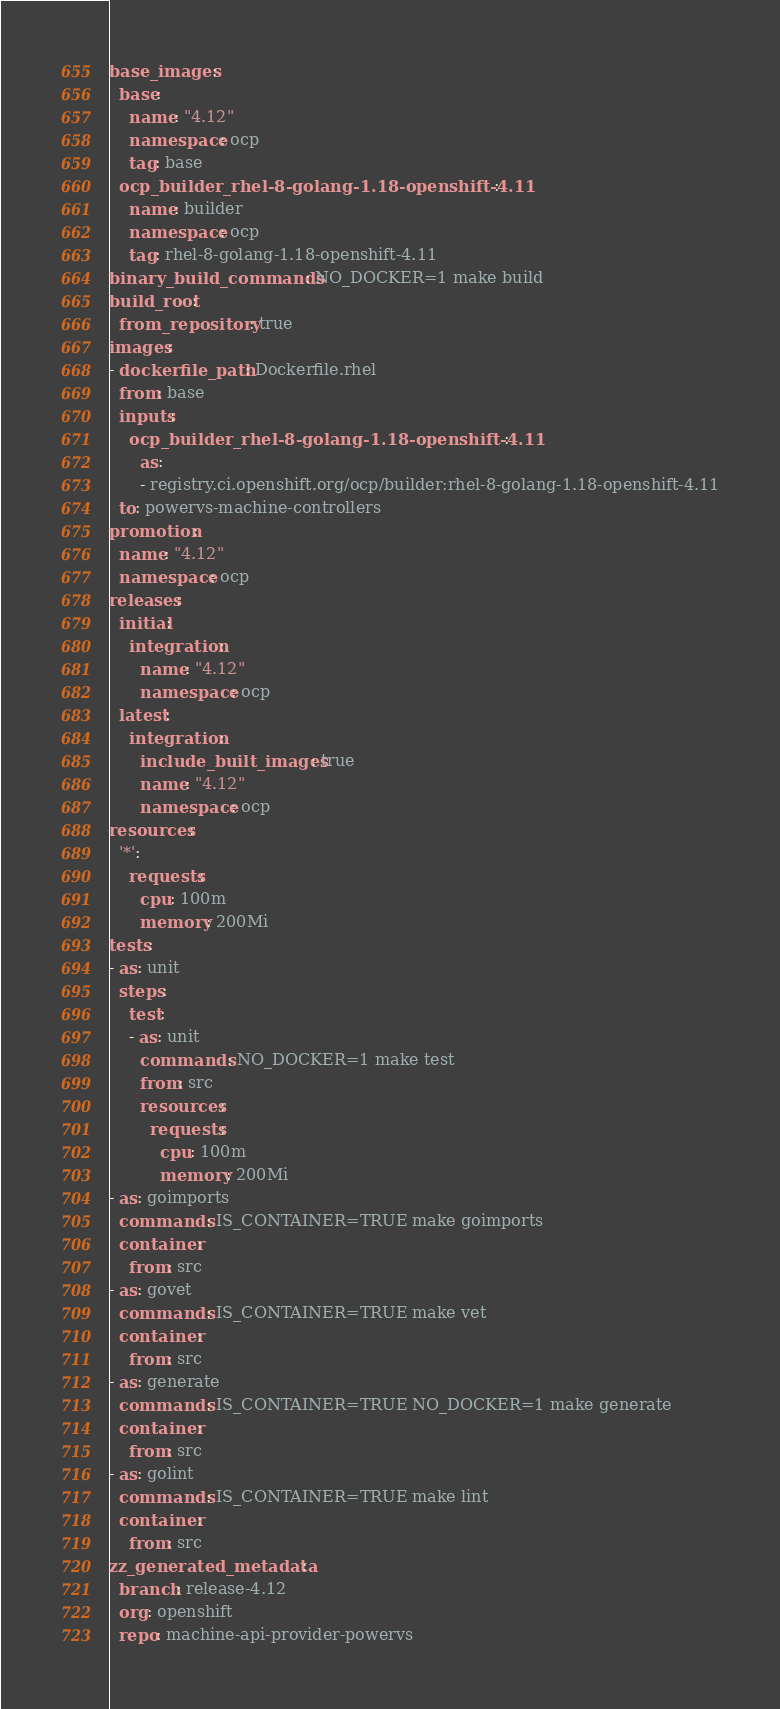<code> <loc_0><loc_0><loc_500><loc_500><_YAML_>base_images:
  base:
    name: "4.12"
    namespace: ocp
    tag: base
  ocp_builder_rhel-8-golang-1.18-openshift-4.11:
    name: builder
    namespace: ocp
    tag: rhel-8-golang-1.18-openshift-4.11
binary_build_commands: NO_DOCKER=1 make build
build_root:
  from_repository: true
images:
- dockerfile_path: Dockerfile.rhel
  from: base
  inputs:
    ocp_builder_rhel-8-golang-1.18-openshift-4.11:
      as:
      - registry.ci.openshift.org/ocp/builder:rhel-8-golang-1.18-openshift-4.11
  to: powervs-machine-controllers
promotion:
  name: "4.12"
  namespace: ocp
releases:
  initial:
    integration:
      name: "4.12"
      namespace: ocp
  latest:
    integration:
      include_built_images: true
      name: "4.12"
      namespace: ocp
resources:
  '*':
    requests:
      cpu: 100m
      memory: 200Mi
tests:
- as: unit
  steps:
    test:
    - as: unit
      commands: NO_DOCKER=1 make test
      from: src
      resources:
        requests:
          cpu: 100m
          memory: 200Mi
- as: goimports
  commands: IS_CONTAINER=TRUE make goimports
  container:
    from: src
- as: govet
  commands: IS_CONTAINER=TRUE make vet
  container:
    from: src
- as: generate
  commands: IS_CONTAINER=TRUE NO_DOCKER=1 make generate
  container:
    from: src
- as: golint
  commands: IS_CONTAINER=TRUE make lint
  container:
    from: src
zz_generated_metadata:
  branch: release-4.12
  org: openshift
  repo: machine-api-provider-powervs
</code> 